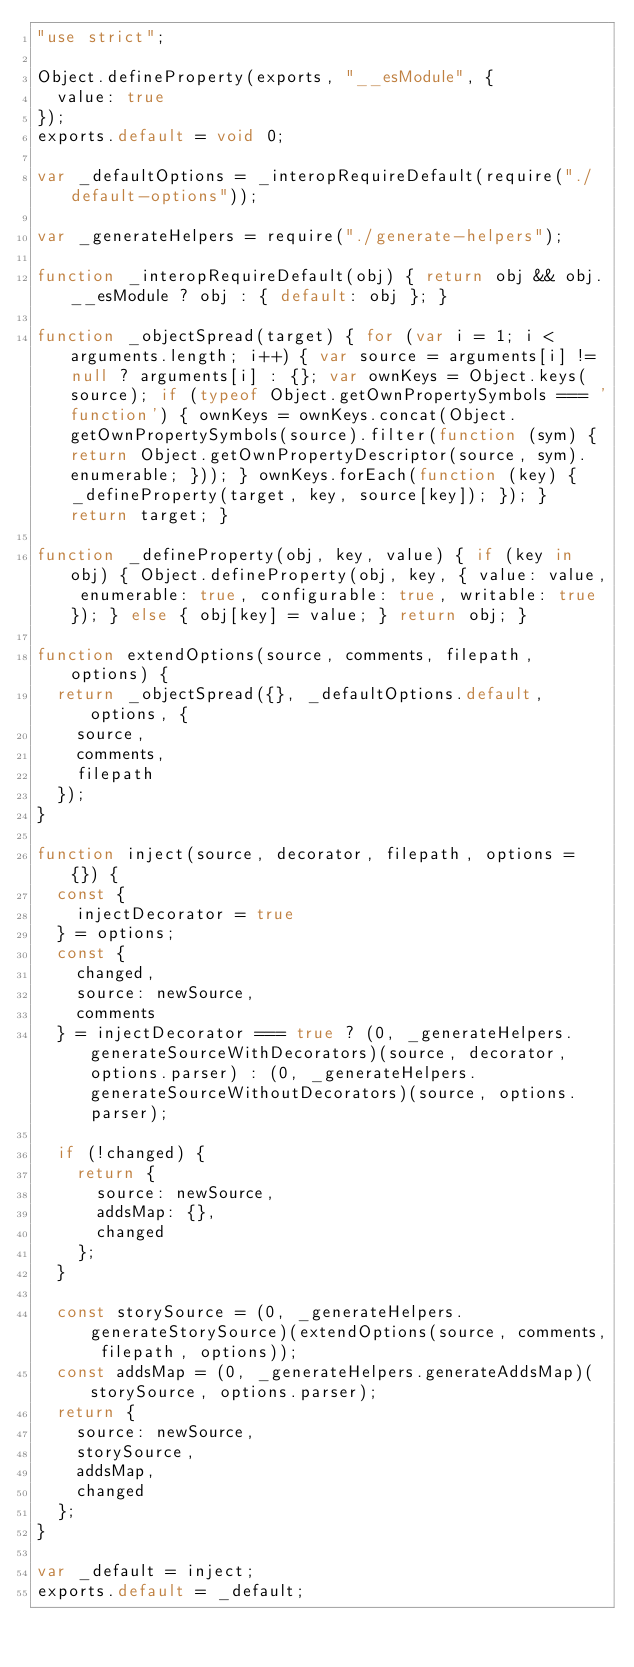Convert code to text. <code><loc_0><loc_0><loc_500><loc_500><_JavaScript_>"use strict";

Object.defineProperty(exports, "__esModule", {
  value: true
});
exports.default = void 0;

var _defaultOptions = _interopRequireDefault(require("./default-options"));

var _generateHelpers = require("./generate-helpers");

function _interopRequireDefault(obj) { return obj && obj.__esModule ? obj : { default: obj }; }

function _objectSpread(target) { for (var i = 1; i < arguments.length; i++) { var source = arguments[i] != null ? arguments[i] : {}; var ownKeys = Object.keys(source); if (typeof Object.getOwnPropertySymbols === 'function') { ownKeys = ownKeys.concat(Object.getOwnPropertySymbols(source).filter(function (sym) { return Object.getOwnPropertyDescriptor(source, sym).enumerable; })); } ownKeys.forEach(function (key) { _defineProperty(target, key, source[key]); }); } return target; }

function _defineProperty(obj, key, value) { if (key in obj) { Object.defineProperty(obj, key, { value: value, enumerable: true, configurable: true, writable: true }); } else { obj[key] = value; } return obj; }

function extendOptions(source, comments, filepath, options) {
  return _objectSpread({}, _defaultOptions.default, options, {
    source,
    comments,
    filepath
  });
}

function inject(source, decorator, filepath, options = {}) {
  const {
    injectDecorator = true
  } = options;
  const {
    changed,
    source: newSource,
    comments
  } = injectDecorator === true ? (0, _generateHelpers.generateSourceWithDecorators)(source, decorator, options.parser) : (0, _generateHelpers.generateSourceWithoutDecorators)(source, options.parser);

  if (!changed) {
    return {
      source: newSource,
      addsMap: {},
      changed
    };
  }

  const storySource = (0, _generateHelpers.generateStorySource)(extendOptions(source, comments, filepath, options));
  const addsMap = (0, _generateHelpers.generateAddsMap)(storySource, options.parser);
  return {
    source: newSource,
    storySource,
    addsMap,
    changed
  };
}

var _default = inject;
exports.default = _default;</code> 